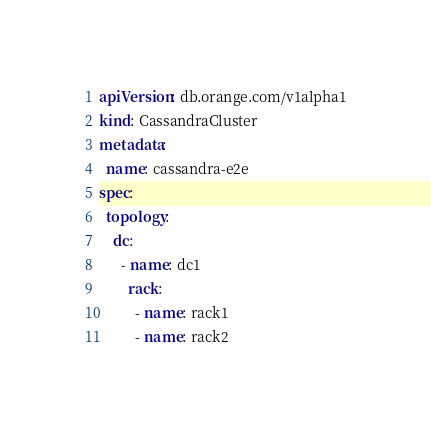Convert code to text. <code><loc_0><loc_0><loc_500><loc_500><_YAML_>apiVersion: db.orange.com/v1alpha1
kind: CassandraCluster
metadata:
  name: cassandra-e2e
spec:
  topology:
    dc:
      - name: dc1
        rack:
          - name: rack1
          - name: rack2
</code> 